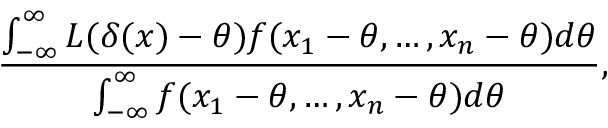<formula> <loc_0><loc_0><loc_500><loc_500>{ \frac { \int _ { - \infty } ^ { \infty } L ( \delta ( x ) - \theta ) f ( x _ { 1 } - \theta , \dots , x _ { n } - \theta ) d \theta } { \int _ { - \infty } ^ { \infty } f ( x _ { 1 } - \theta , \dots , x _ { n } - \theta ) d \theta } } ,</formula> 